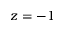Convert formula to latex. <formula><loc_0><loc_0><loc_500><loc_500>z = - 1</formula> 